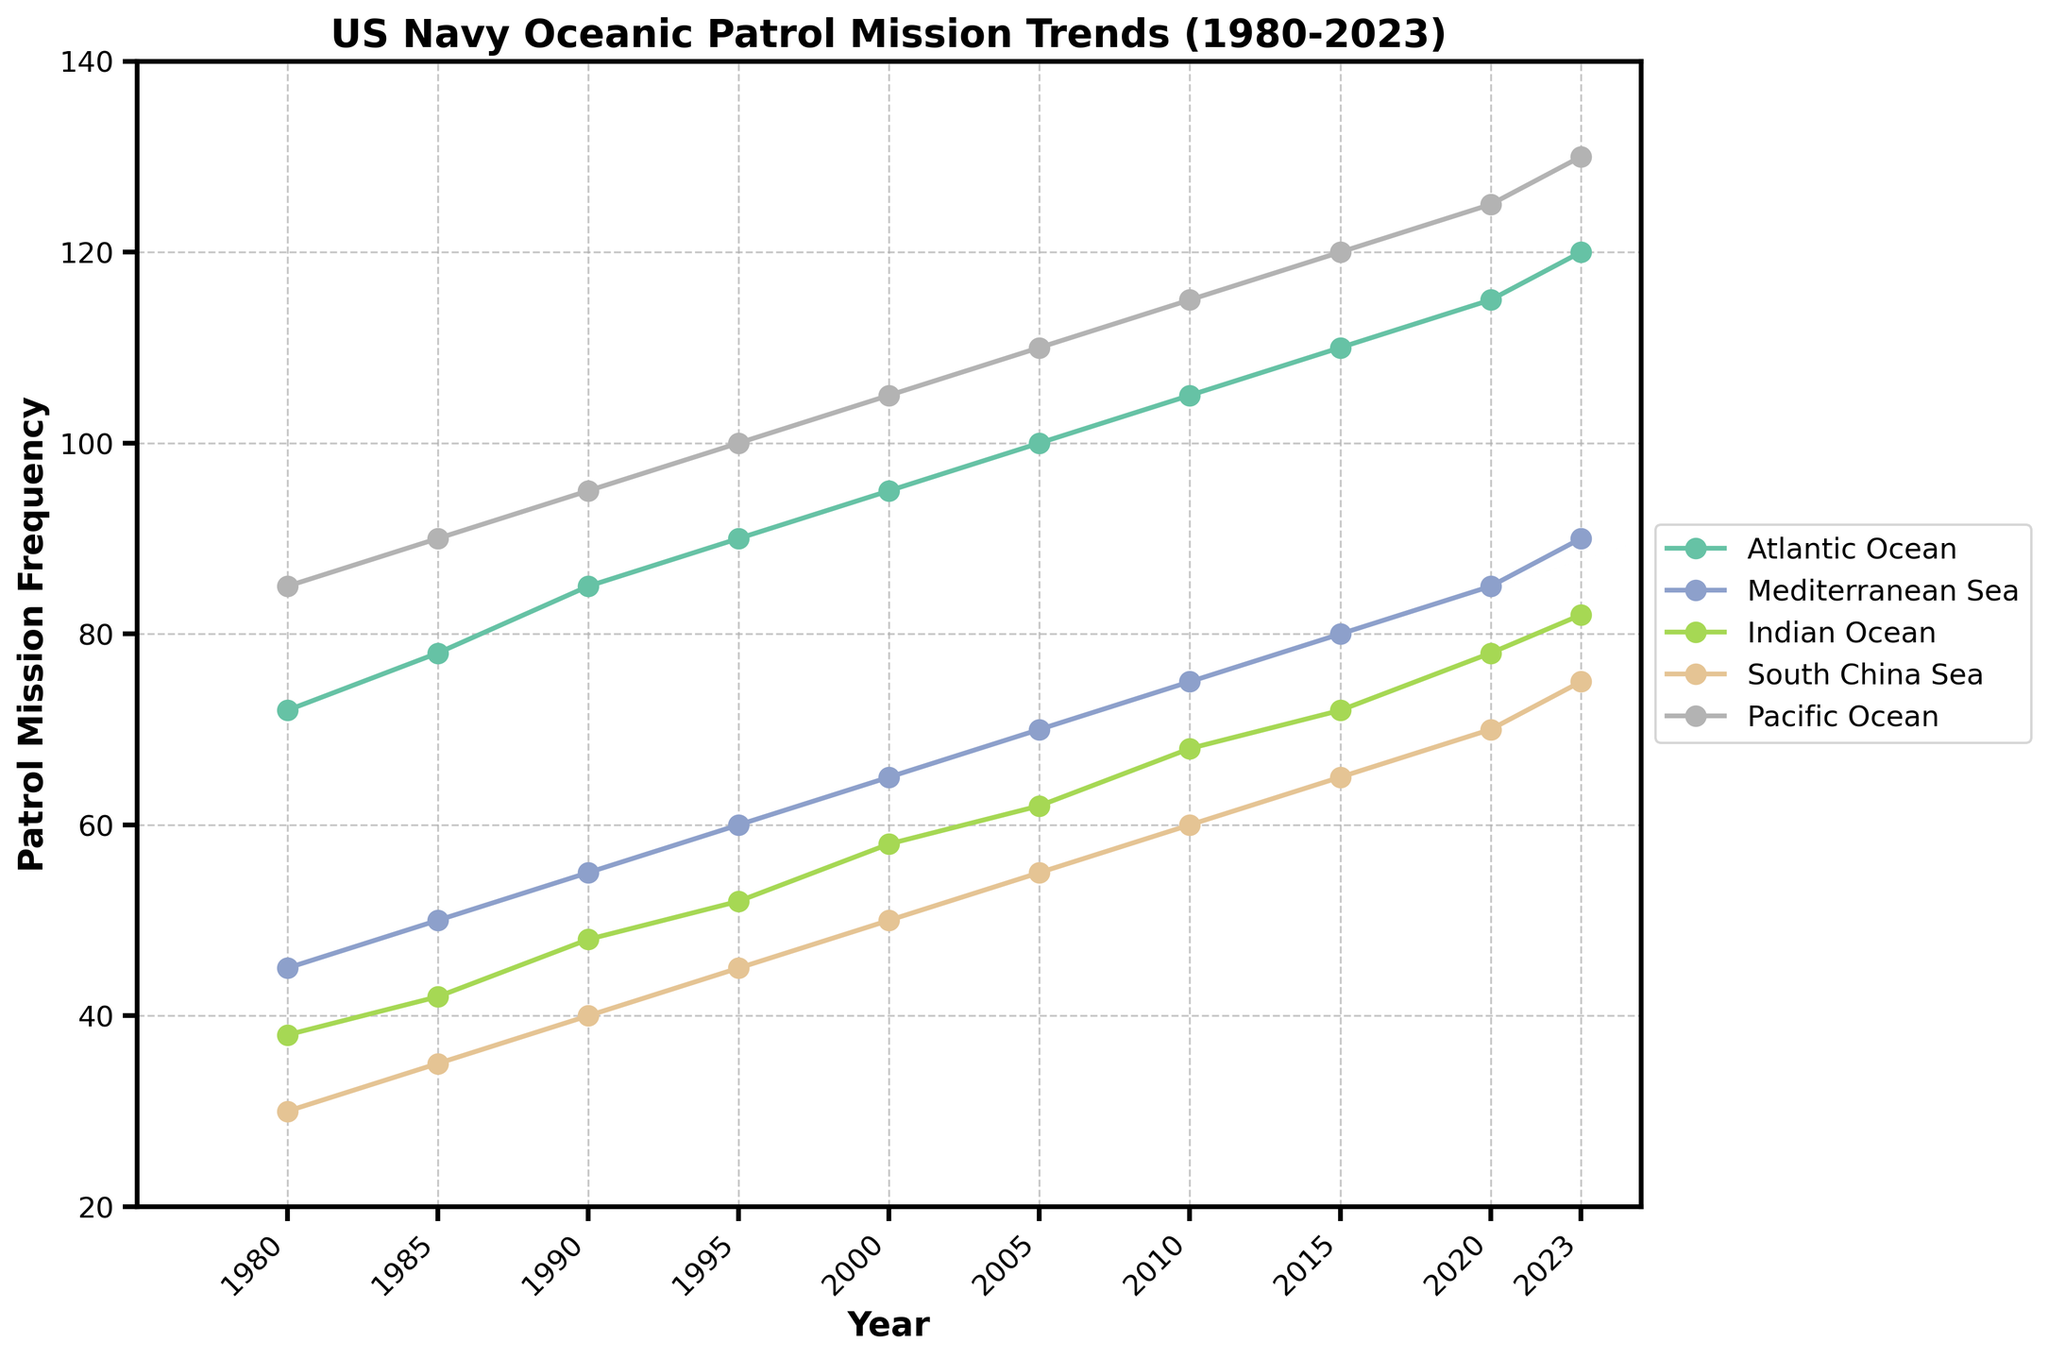What was the patrol mission frequency in the Atlantic Ocean in 2000? Find the value on the Y-axis corresponding to the Atlantic Ocean line in the year 2000.
Answer: 95 Which ocean had the highest patrol mission frequency in 1985? Compare the Y values for all regions in the year 1985.
Answer: Pacific Ocean Between 1980 and 2023, which region showed the highest overall increase in patrol mission frequency? Subtract the value in 1980 from that in 2023 for each region and find the one with the largest difference.
Answer: Pacific Ocean What is the average patrol mission frequency in the Indian Ocean from 1990 to 2020? Add the patrol frequencies of the Indian Ocean for the years 1990, 1995, 2000, 2005, 2010, 2015, 2020, then divide by 7.
Answer: 62.57 In which year did the Mediterranean Sea surpass a patrol frequency of 75? Look for the first year in the Mediterranean Sea line where the value exceeds 75.
Answer: 2010 Compare the patrol frequencies of the South China Sea and the Indian Ocean in 2015. Which was higher and by how much? Subtract the South China Sea patrol frequency from the Indian Ocean patrol frequency in 2015.
Answer: Indian Ocean by 7 What trend is observed for the patrol missions in the Pacific Ocean from 1980 to 2023? Observe the line corresponding to the Pacific Ocean and describe its trajectory.
Answer: Increasing Which two regions had the closest patrol frequencies in 2023? Subtract the patrol frequencies of each pair of regions in 2023 and find the pair with the smallest difference.
Answer: Atlantic Ocean & Mediterranean Sea By how much did the patrol mission frequency in the Atlantic Ocean increase from 1980 to 1990? Subtract the patrol frequency in 1980 from that in 1990 in the Atlantic Ocean.
Answer: 13 What is the visual color representation of the Mediterranean Sea line on the plot? Identify the color of the line labeled Mediterranean Sea on the plot.
Answer: Dark Blue 